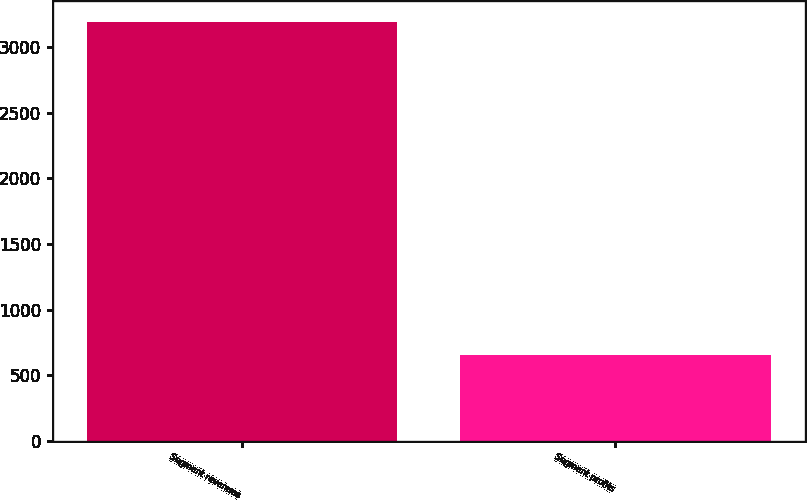Convert chart to OTSL. <chart><loc_0><loc_0><loc_500><loc_500><bar_chart><fcel>Segment revenues<fcel>Segment profits<nl><fcel>3193<fcel>651<nl></chart> 